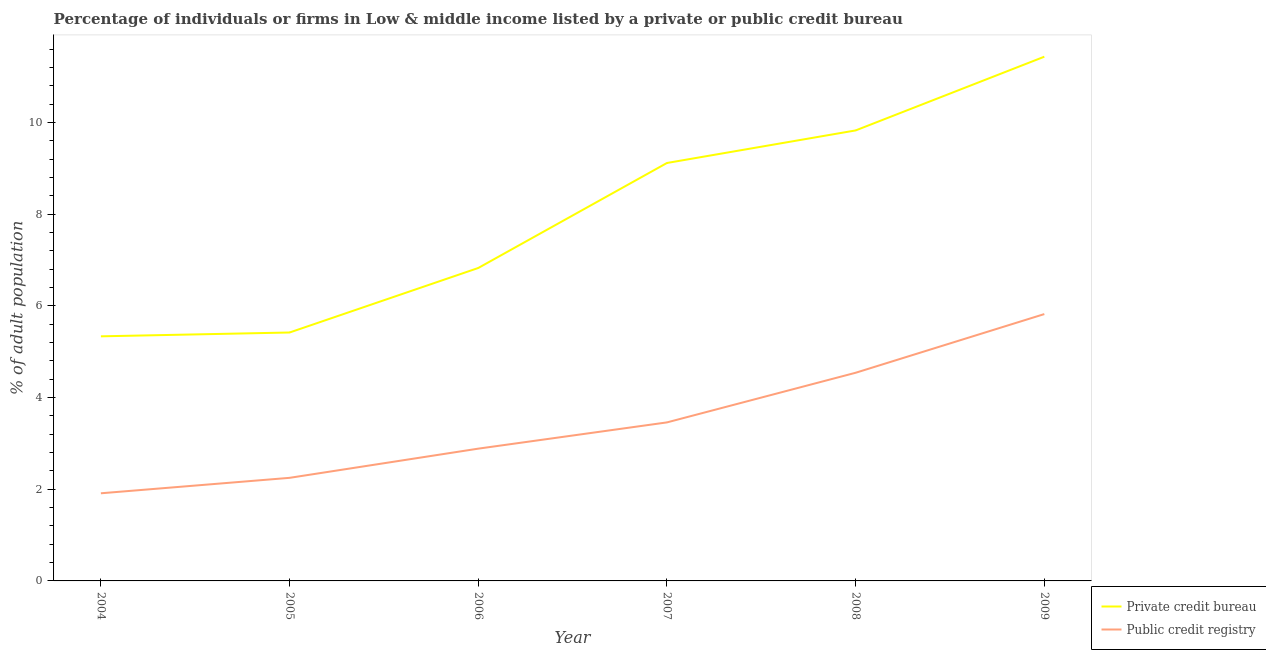How many different coloured lines are there?
Offer a very short reply. 2. Does the line corresponding to percentage of firms listed by private credit bureau intersect with the line corresponding to percentage of firms listed by public credit bureau?
Your answer should be compact. No. What is the percentage of firms listed by private credit bureau in 2004?
Your answer should be compact. 5.34. Across all years, what is the maximum percentage of firms listed by public credit bureau?
Ensure brevity in your answer.  5.82. Across all years, what is the minimum percentage of firms listed by private credit bureau?
Your answer should be very brief. 5.34. In which year was the percentage of firms listed by public credit bureau minimum?
Your response must be concise. 2004. What is the total percentage of firms listed by public credit bureau in the graph?
Provide a short and direct response. 20.87. What is the difference between the percentage of firms listed by public credit bureau in 2005 and that in 2007?
Make the answer very short. -1.21. What is the difference between the percentage of firms listed by public credit bureau in 2007 and the percentage of firms listed by private credit bureau in 2008?
Your response must be concise. -6.37. What is the average percentage of firms listed by public credit bureau per year?
Provide a succinct answer. 3.48. In the year 2004, what is the difference between the percentage of firms listed by public credit bureau and percentage of firms listed by private credit bureau?
Provide a succinct answer. -3.42. What is the ratio of the percentage of firms listed by public credit bureau in 2007 to that in 2009?
Provide a short and direct response. 0.59. Is the difference between the percentage of firms listed by private credit bureau in 2004 and 2008 greater than the difference between the percentage of firms listed by public credit bureau in 2004 and 2008?
Provide a succinct answer. No. What is the difference between the highest and the second highest percentage of firms listed by public credit bureau?
Your answer should be very brief. 1.28. What is the difference between the highest and the lowest percentage of firms listed by private credit bureau?
Make the answer very short. 6.1. In how many years, is the percentage of firms listed by private credit bureau greater than the average percentage of firms listed by private credit bureau taken over all years?
Give a very brief answer. 3. Is the sum of the percentage of firms listed by private credit bureau in 2004 and 2009 greater than the maximum percentage of firms listed by public credit bureau across all years?
Ensure brevity in your answer.  Yes. Is the percentage of firms listed by private credit bureau strictly greater than the percentage of firms listed by public credit bureau over the years?
Your answer should be very brief. Yes. Is the percentage of firms listed by private credit bureau strictly less than the percentage of firms listed by public credit bureau over the years?
Give a very brief answer. No. How many lines are there?
Your response must be concise. 2. What is the difference between two consecutive major ticks on the Y-axis?
Keep it short and to the point. 2. Where does the legend appear in the graph?
Offer a terse response. Bottom right. What is the title of the graph?
Keep it short and to the point. Percentage of individuals or firms in Low & middle income listed by a private or public credit bureau. Does "Taxes on exports" appear as one of the legend labels in the graph?
Offer a terse response. No. What is the label or title of the Y-axis?
Provide a succinct answer. % of adult population. What is the % of adult population of Private credit bureau in 2004?
Your answer should be compact. 5.34. What is the % of adult population of Public credit registry in 2004?
Ensure brevity in your answer.  1.91. What is the % of adult population of Private credit bureau in 2005?
Give a very brief answer. 5.42. What is the % of adult population of Public credit registry in 2005?
Your answer should be compact. 2.25. What is the % of adult population in Private credit bureau in 2006?
Ensure brevity in your answer.  6.83. What is the % of adult population of Public credit registry in 2006?
Make the answer very short. 2.89. What is the % of adult population in Private credit bureau in 2007?
Ensure brevity in your answer.  9.12. What is the % of adult population in Public credit registry in 2007?
Keep it short and to the point. 3.46. What is the % of adult population of Private credit bureau in 2008?
Provide a short and direct response. 9.83. What is the % of adult population in Public credit registry in 2008?
Keep it short and to the point. 4.54. What is the % of adult population of Private credit bureau in 2009?
Your answer should be compact. 11.44. What is the % of adult population of Public credit registry in 2009?
Your answer should be very brief. 5.82. Across all years, what is the maximum % of adult population of Private credit bureau?
Provide a succinct answer. 11.44. Across all years, what is the maximum % of adult population of Public credit registry?
Give a very brief answer. 5.82. Across all years, what is the minimum % of adult population in Private credit bureau?
Your response must be concise. 5.34. Across all years, what is the minimum % of adult population in Public credit registry?
Give a very brief answer. 1.91. What is the total % of adult population in Private credit bureau in the graph?
Offer a very short reply. 47.96. What is the total % of adult population of Public credit registry in the graph?
Keep it short and to the point. 20.87. What is the difference between the % of adult population of Private credit bureau in 2004 and that in 2005?
Provide a short and direct response. -0.08. What is the difference between the % of adult population in Public credit registry in 2004 and that in 2005?
Provide a short and direct response. -0.34. What is the difference between the % of adult population in Private credit bureau in 2004 and that in 2006?
Your response must be concise. -1.49. What is the difference between the % of adult population of Public credit registry in 2004 and that in 2006?
Give a very brief answer. -0.97. What is the difference between the % of adult population of Private credit bureau in 2004 and that in 2007?
Provide a short and direct response. -3.78. What is the difference between the % of adult population of Public credit registry in 2004 and that in 2007?
Your response must be concise. -1.55. What is the difference between the % of adult population in Private credit bureau in 2004 and that in 2008?
Keep it short and to the point. -4.49. What is the difference between the % of adult population in Public credit registry in 2004 and that in 2008?
Your response must be concise. -2.63. What is the difference between the % of adult population of Private credit bureau in 2004 and that in 2009?
Ensure brevity in your answer.  -6.1. What is the difference between the % of adult population in Public credit registry in 2004 and that in 2009?
Your answer should be very brief. -3.91. What is the difference between the % of adult population in Private credit bureau in 2005 and that in 2006?
Ensure brevity in your answer.  -1.41. What is the difference between the % of adult population in Public credit registry in 2005 and that in 2006?
Give a very brief answer. -0.64. What is the difference between the % of adult population of Private credit bureau in 2005 and that in 2007?
Keep it short and to the point. -3.7. What is the difference between the % of adult population of Public credit registry in 2005 and that in 2007?
Provide a short and direct response. -1.21. What is the difference between the % of adult population in Private credit bureau in 2005 and that in 2008?
Your response must be concise. -4.41. What is the difference between the % of adult population in Public credit registry in 2005 and that in 2008?
Make the answer very short. -2.29. What is the difference between the % of adult population of Private credit bureau in 2005 and that in 2009?
Offer a very short reply. -6.02. What is the difference between the % of adult population of Public credit registry in 2005 and that in 2009?
Give a very brief answer. -3.57. What is the difference between the % of adult population in Private credit bureau in 2006 and that in 2007?
Offer a very short reply. -2.29. What is the difference between the % of adult population in Public credit registry in 2006 and that in 2007?
Offer a very short reply. -0.57. What is the difference between the % of adult population in Private credit bureau in 2006 and that in 2008?
Ensure brevity in your answer.  -3. What is the difference between the % of adult population of Public credit registry in 2006 and that in 2008?
Ensure brevity in your answer.  -1.66. What is the difference between the % of adult population of Private credit bureau in 2006 and that in 2009?
Your response must be concise. -4.61. What is the difference between the % of adult population of Public credit registry in 2006 and that in 2009?
Offer a terse response. -2.94. What is the difference between the % of adult population of Private credit bureau in 2007 and that in 2008?
Provide a succinct answer. -0.71. What is the difference between the % of adult population of Public credit registry in 2007 and that in 2008?
Your answer should be very brief. -1.08. What is the difference between the % of adult population in Private credit bureau in 2007 and that in 2009?
Your answer should be very brief. -2.32. What is the difference between the % of adult population of Public credit registry in 2007 and that in 2009?
Your answer should be compact. -2.36. What is the difference between the % of adult population of Private credit bureau in 2008 and that in 2009?
Your answer should be very brief. -1.61. What is the difference between the % of adult population of Public credit registry in 2008 and that in 2009?
Offer a very short reply. -1.28. What is the difference between the % of adult population of Private credit bureau in 2004 and the % of adult population of Public credit registry in 2005?
Ensure brevity in your answer.  3.09. What is the difference between the % of adult population of Private credit bureau in 2004 and the % of adult population of Public credit registry in 2006?
Provide a succinct answer. 2.45. What is the difference between the % of adult population in Private credit bureau in 2004 and the % of adult population in Public credit registry in 2007?
Offer a very short reply. 1.88. What is the difference between the % of adult population of Private credit bureau in 2004 and the % of adult population of Public credit registry in 2008?
Provide a succinct answer. 0.79. What is the difference between the % of adult population in Private credit bureau in 2004 and the % of adult population in Public credit registry in 2009?
Provide a short and direct response. -0.49. What is the difference between the % of adult population in Private credit bureau in 2005 and the % of adult population in Public credit registry in 2006?
Offer a very short reply. 2.53. What is the difference between the % of adult population of Private credit bureau in 2005 and the % of adult population of Public credit registry in 2007?
Provide a succinct answer. 1.96. What is the difference between the % of adult population of Private credit bureau in 2005 and the % of adult population of Public credit registry in 2008?
Ensure brevity in your answer.  0.88. What is the difference between the % of adult population of Private credit bureau in 2005 and the % of adult population of Public credit registry in 2009?
Offer a terse response. -0.4. What is the difference between the % of adult population of Private credit bureau in 2006 and the % of adult population of Public credit registry in 2007?
Provide a short and direct response. 3.37. What is the difference between the % of adult population in Private credit bureau in 2006 and the % of adult population in Public credit registry in 2008?
Your response must be concise. 2.29. What is the difference between the % of adult population in Private credit bureau in 2007 and the % of adult population in Public credit registry in 2008?
Keep it short and to the point. 4.58. What is the difference between the % of adult population of Private credit bureau in 2007 and the % of adult population of Public credit registry in 2009?
Provide a succinct answer. 3.3. What is the difference between the % of adult population in Private credit bureau in 2008 and the % of adult population in Public credit registry in 2009?
Offer a very short reply. 4.01. What is the average % of adult population in Private credit bureau per year?
Make the answer very short. 7.99. What is the average % of adult population in Public credit registry per year?
Your answer should be compact. 3.48. In the year 2004, what is the difference between the % of adult population in Private credit bureau and % of adult population in Public credit registry?
Your response must be concise. 3.42. In the year 2005, what is the difference between the % of adult population of Private credit bureau and % of adult population of Public credit registry?
Offer a very short reply. 3.17. In the year 2006, what is the difference between the % of adult population in Private credit bureau and % of adult population in Public credit registry?
Your answer should be very brief. 3.94. In the year 2007, what is the difference between the % of adult population in Private credit bureau and % of adult population in Public credit registry?
Your response must be concise. 5.66. In the year 2008, what is the difference between the % of adult population in Private credit bureau and % of adult population in Public credit registry?
Ensure brevity in your answer.  5.29. In the year 2009, what is the difference between the % of adult population in Private credit bureau and % of adult population in Public credit registry?
Your answer should be compact. 5.61. What is the ratio of the % of adult population of Private credit bureau in 2004 to that in 2005?
Your response must be concise. 0.98. What is the ratio of the % of adult population in Public credit registry in 2004 to that in 2005?
Your answer should be very brief. 0.85. What is the ratio of the % of adult population in Private credit bureau in 2004 to that in 2006?
Offer a terse response. 0.78. What is the ratio of the % of adult population in Public credit registry in 2004 to that in 2006?
Offer a very short reply. 0.66. What is the ratio of the % of adult population in Private credit bureau in 2004 to that in 2007?
Keep it short and to the point. 0.59. What is the ratio of the % of adult population of Public credit registry in 2004 to that in 2007?
Ensure brevity in your answer.  0.55. What is the ratio of the % of adult population of Private credit bureau in 2004 to that in 2008?
Your answer should be very brief. 0.54. What is the ratio of the % of adult population in Public credit registry in 2004 to that in 2008?
Your response must be concise. 0.42. What is the ratio of the % of adult population of Private credit bureau in 2004 to that in 2009?
Offer a terse response. 0.47. What is the ratio of the % of adult population of Public credit registry in 2004 to that in 2009?
Your response must be concise. 0.33. What is the ratio of the % of adult population in Private credit bureau in 2005 to that in 2006?
Make the answer very short. 0.79. What is the ratio of the % of adult population of Public credit registry in 2005 to that in 2006?
Ensure brevity in your answer.  0.78. What is the ratio of the % of adult population of Private credit bureau in 2005 to that in 2007?
Offer a terse response. 0.59. What is the ratio of the % of adult population of Public credit registry in 2005 to that in 2007?
Ensure brevity in your answer.  0.65. What is the ratio of the % of adult population of Private credit bureau in 2005 to that in 2008?
Keep it short and to the point. 0.55. What is the ratio of the % of adult population of Public credit registry in 2005 to that in 2008?
Offer a terse response. 0.5. What is the ratio of the % of adult population of Private credit bureau in 2005 to that in 2009?
Make the answer very short. 0.47. What is the ratio of the % of adult population in Public credit registry in 2005 to that in 2009?
Your response must be concise. 0.39. What is the ratio of the % of adult population in Private credit bureau in 2006 to that in 2007?
Provide a short and direct response. 0.75. What is the ratio of the % of adult population of Public credit registry in 2006 to that in 2007?
Offer a terse response. 0.83. What is the ratio of the % of adult population in Private credit bureau in 2006 to that in 2008?
Your answer should be very brief. 0.69. What is the ratio of the % of adult population in Public credit registry in 2006 to that in 2008?
Offer a terse response. 0.64. What is the ratio of the % of adult population of Private credit bureau in 2006 to that in 2009?
Give a very brief answer. 0.6. What is the ratio of the % of adult population in Public credit registry in 2006 to that in 2009?
Your answer should be very brief. 0.5. What is the ratio of the % of adult population of Private credit bureau in 2007 to that in 2008?
Your answer should be very brief. 0.93. What is the ratio of the % of adult population in Public credit registry in 2007 to that in 2008?
Give a very brief answer. 0.76. What is the ratio of the % of adult population of Private credit bureau in 2007 to that in 2009?
Ensure brevity in your answer.  0.8. What is the ratio of the % of adult population in Public credit registry in 2007 to that in 2009?
Keep it short and to the point. 0.59. What is the ratio of the % of adult population in Private credit bureau in 2008 to that in 2009?
Make the answer very short. 0.86. What is the ratio of the % of adult population in Public credit registry in 2008 to that in 2009?
Offer a very short reply. 0.78. What is the difference between the highest and the second highest % of adult population in Private credit bureau?
Offer a very short reply. 1.61. What is the difference between the highest and the second highest % of adult population in Public credit registry?
Your answer should be compact. 1.28. What is the difference between the highest and the lowest % of adult population in Private credit bureau?
Keep it short and to the point. 6.1. What is the difference between the highest and the lowest % of adult population in Public credit registry?
Give a very brief answer. 3.91. 